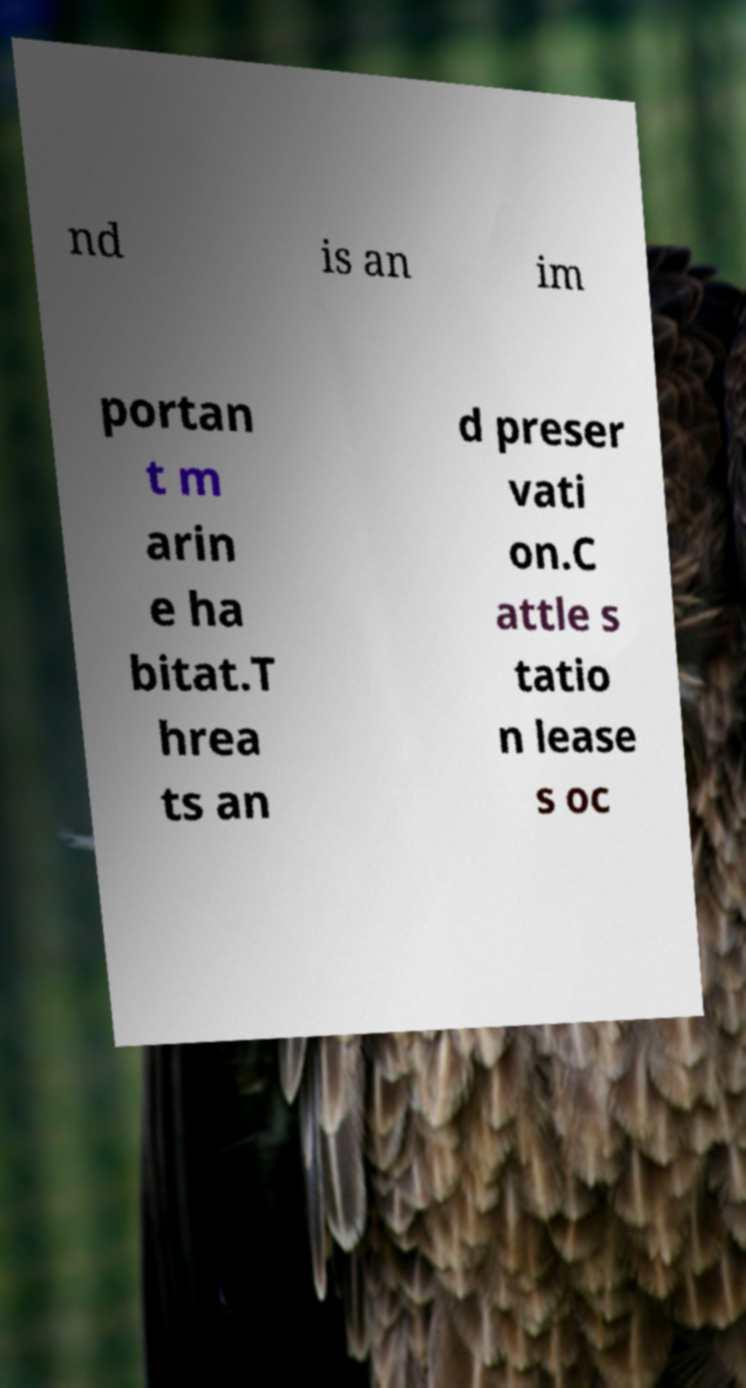What messages or text are displayed in this image? I need them in a readable, typed format. nd is an im portan t m arin e ha bitat.T hrea ts an d preser vati on.C attle s tatio n lease s oc 